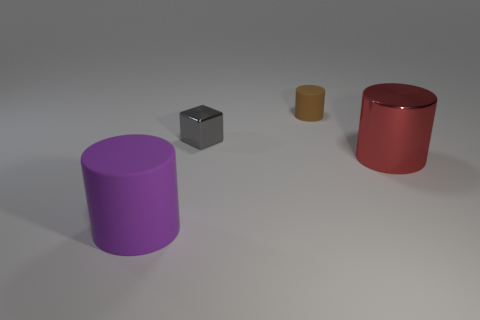Add 1 cylinders. How many objects exist? 5 Subtract all cylinders. How many objects are left? 1 Add 3 tiny brown cylinders. How many tiny brown cylinders are left? 4 Add 1 big green matte things. How many big green matte things exist? 1 Subtract 0 yellow blocks. How many objects are left? 4 Subtract all brown matte things. Subtract all big matte cylinders. How many objects are left? 2 